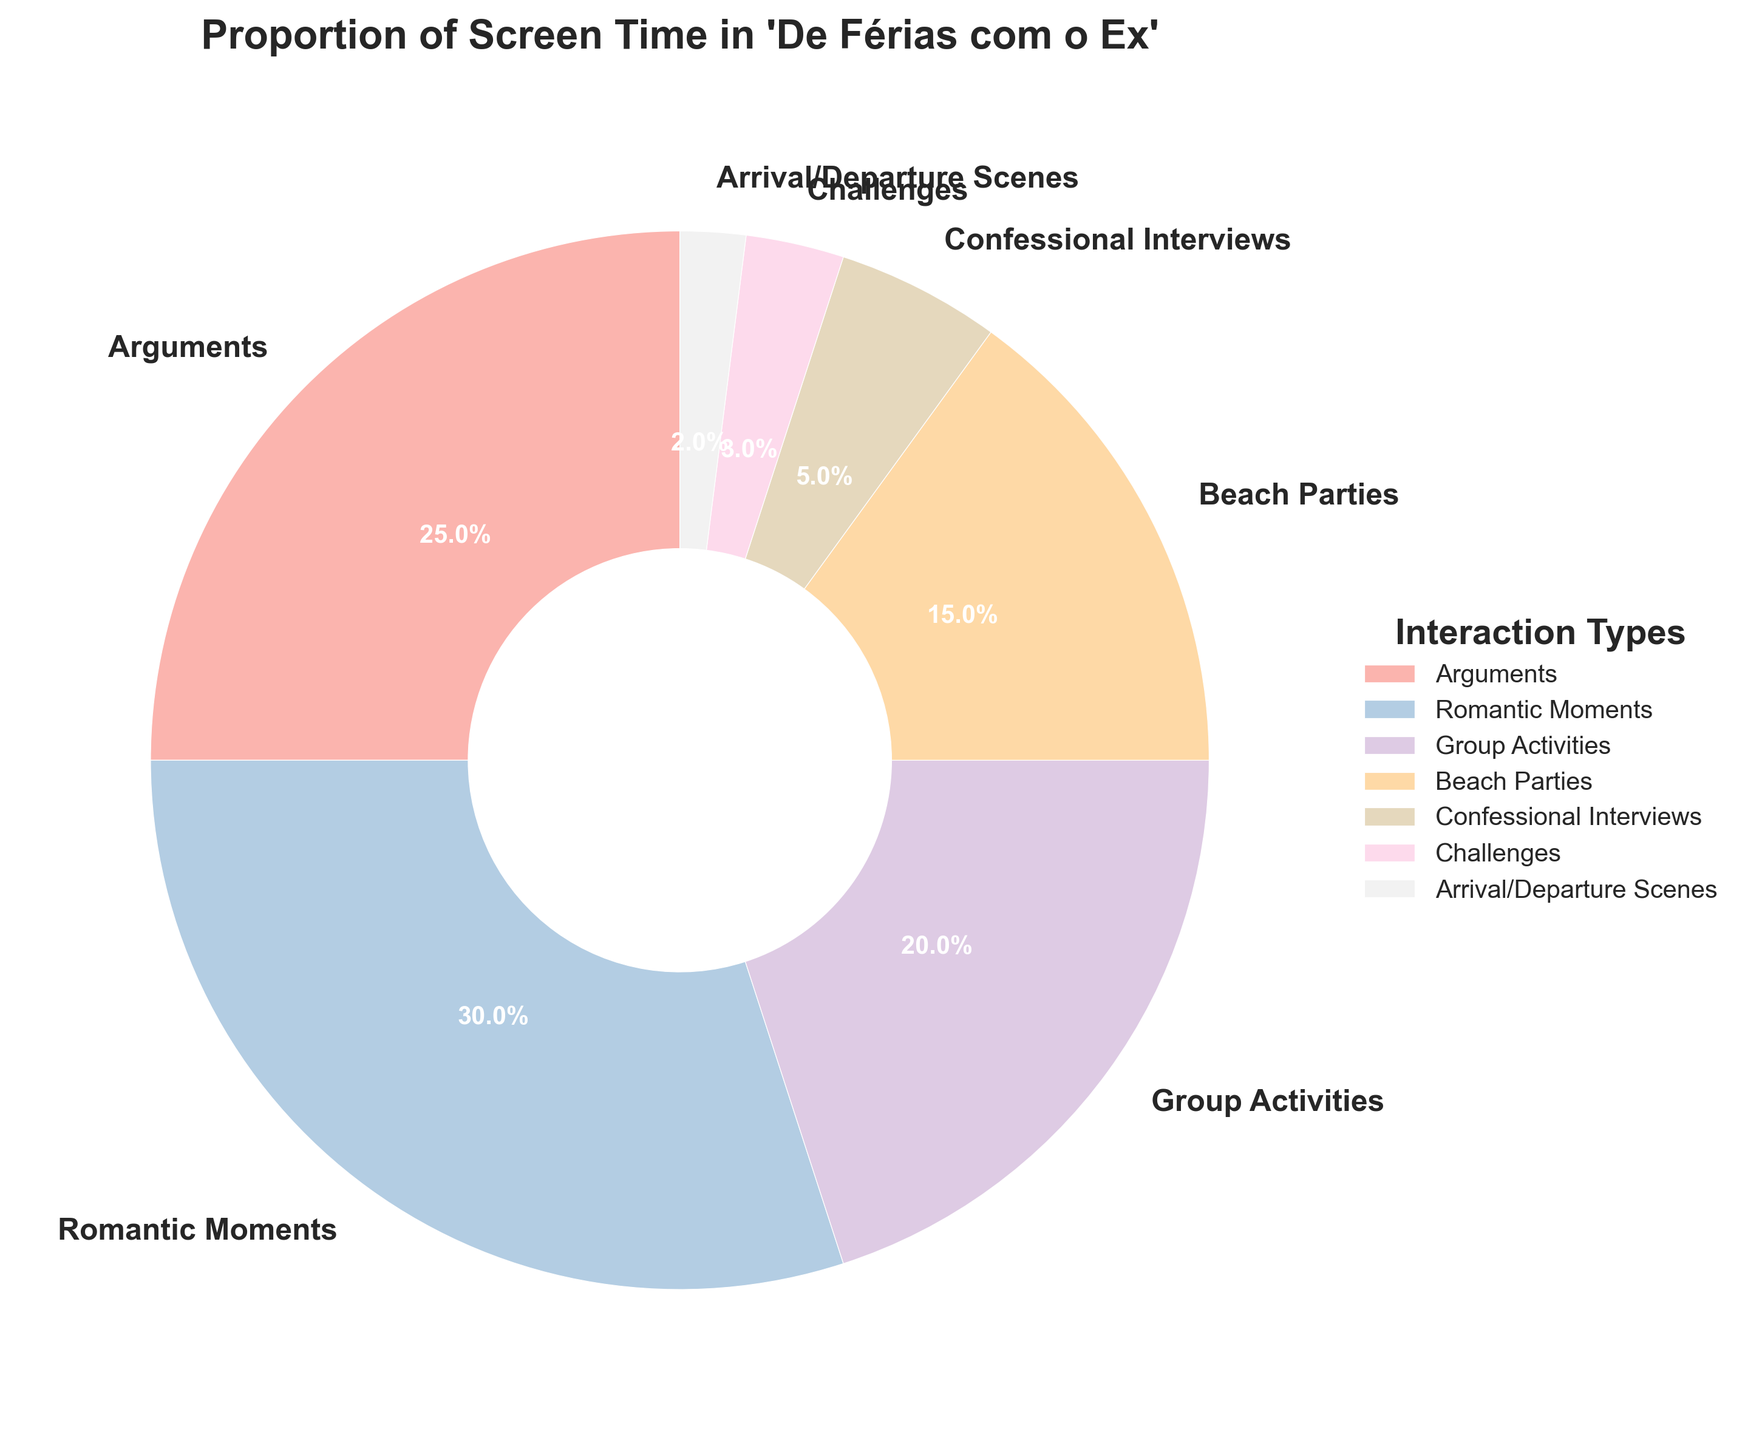What proportion of screen time is spent on romantic moments and beach parties combined? To find this, you need to add the percentage of screen time for romantic moments (30%) and beach parties (15%), which gives 30 + 15 = 45%.
Answer: 45% Which interaction type has the least screen time? From the pie chart, the interaction type with the smallest wedge represents the least screen time. The percentage for Arrival/Departure Scenes is the smallest at 2%.
Answer: Arrival/Departure Scenes Compare the screen time for arguments and challenges. Which one is more, and by how much? The screen time for arguments is 25%, and the screen time for challenges is 3%. To find the difference, subtract the smaller percentage from the larger one: 25 - 3 = 22%.
Answer: Arguments have 22% more screen time What is the combined screen time percentage for non-group interactions (arguments, romantic moments, confessional interviews)? Add the percentages for arguments (25%), romantic moments (30%), and confessional interviews (5%): 25 + 30 + 5 = 60%.
Answer: 60% Among the listed interaction types, which two combined can reach exactly half of the total screen time? To get 50%, sum the percentages of various combinations: 
- Arguments (25%) + Romantic Moments (30%) = 55%
- Romantic Moments (30%) + Group Activities (20%) = 50%
Thus, Romantic Moments and Group Activities combined equal half of the total screen time.
Answer: Romantic Moments and Group Activities Is there more screen time allocated to individual interactions (arguments, romantic moments, confessional interviews) or group interactions (group activities, beach parties, challenges, arrival/departure scenes)? Sum the percentages for individual interactions:
- Arguments (25%) + Romantic Moments (30%) + Confessional Interviews (5%) = 60%
Sum the percentages for group interactions:
- Group Activities (20%) + Beach Parties (15%) + Challenges (3%) + Arrival/Departure Scenes (2%) = 40%
So there is more screen time for individual interactions.
Answer: Individual interactions Which interaction type occupies more screen time: beach parties or confessional interviews? From the pie chart, beach parties have 15% screen time, while confessional interviews have 5%. Beach parties occupy more screen time.
Answer: Beach Parties If the screen time for romantic moments increased by 10%, what would the new proportion be? Initially, romantic moments account for 30%. Adding 10%, the new proportion would be 30 + 10 = 40%.
Answer: 40% Which interaction types together account for at least 70% of the screen time? Adding the screen times until reaching at least 70%:
- Arguments (25%) + Romantic Moments (30%) + Group Activities (20%) = 75%
Thus, arguments, romantic moments, and group activities together account for 75%, which is at least 70%.
Answer: Arguments, Romantic Moments, and Group Activities What's the average percentage of the interaction types' screen time? To find the average, add all the percentages and divide by the number of interaction types:
(25 + 30 + 20 + 15 + 5 + 3 + 2) / 7 = 100 / 7 ≈ 14.29%.
Answer: 14.29% 